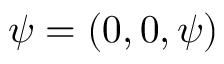<formula> <loc_0><loc_0><loc_500><loc_500>\psi = ( 0 , 0 , \psi )</formula> 